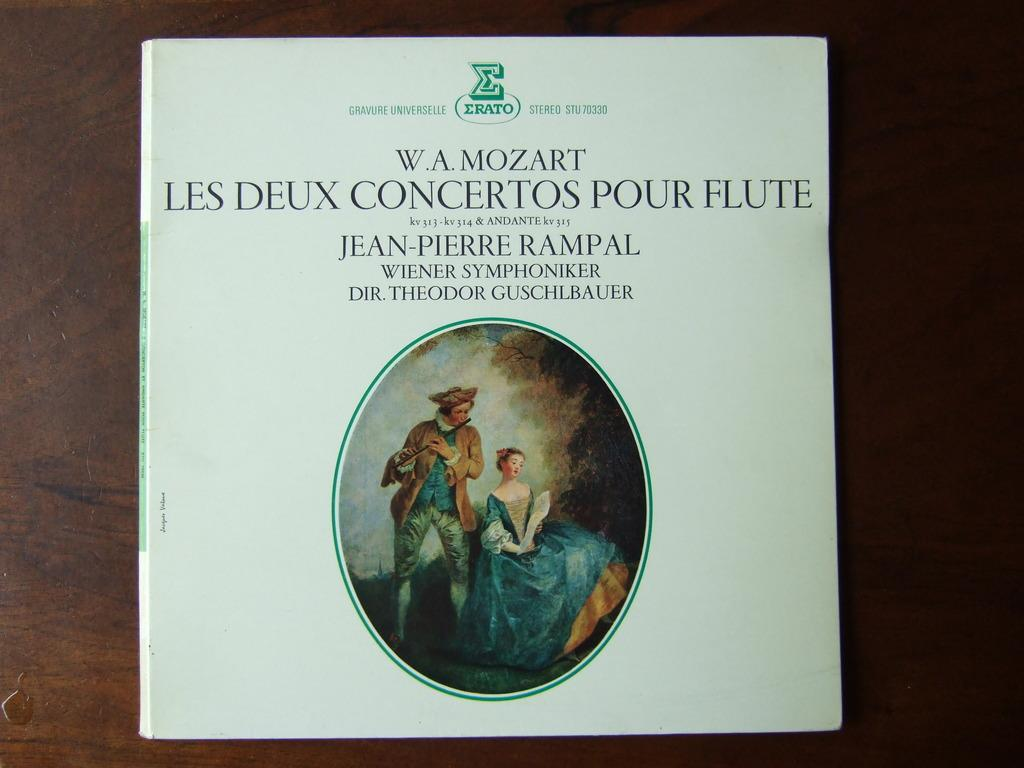<image>
Offer a succinct explanation of the picture presented. A book pertaining to Mozart has a picture on the cover. 